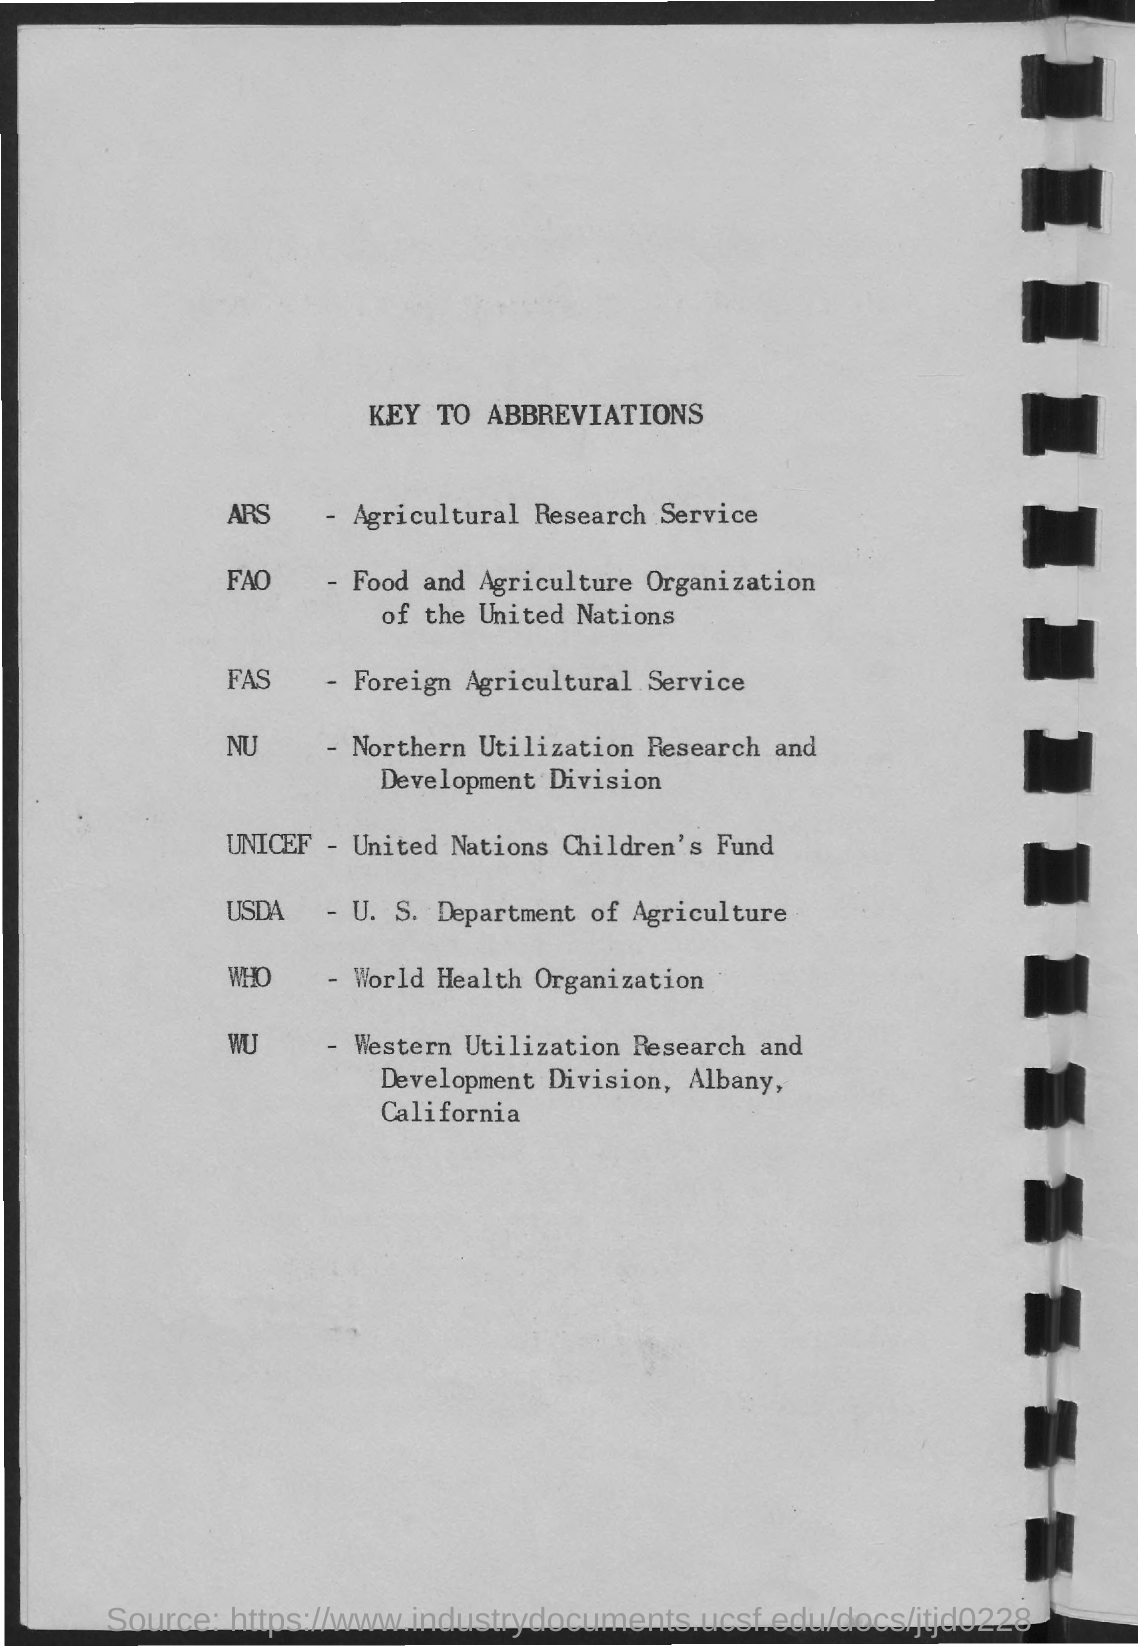What does fas stands for?
Provide a succinct answer. Foreign Agricultural Service. What does WHO stands for?
Make the answer very short. World Health Organization. What does UNICEF stands for?
Ensure brevity in your answer.  United Nations Children's Fund. 